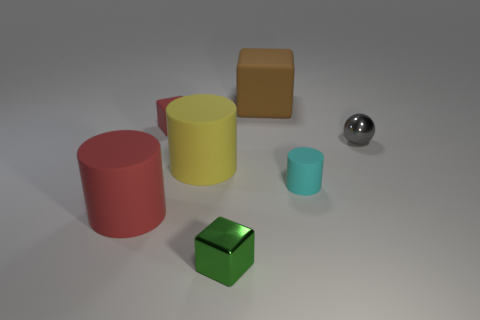The large matte thing that is the same color as the tiny matte cube is what shape? The large object sharing the same matte brown color as the tiny cube is cylindrical in shape. 